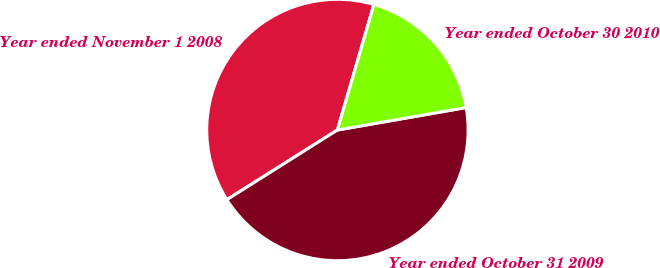Convert chart to OTSL. <chart><loc_0><loc_0><loc_500><loc_500><pie_chart><fcel>Year ended November 1 2008<fcel>Year ended October 31 2009<fcel>Year ended October 30 2010<nl><fcel>38.45%<fcel>43.8%<fcel>17.75%<nl></chart> 